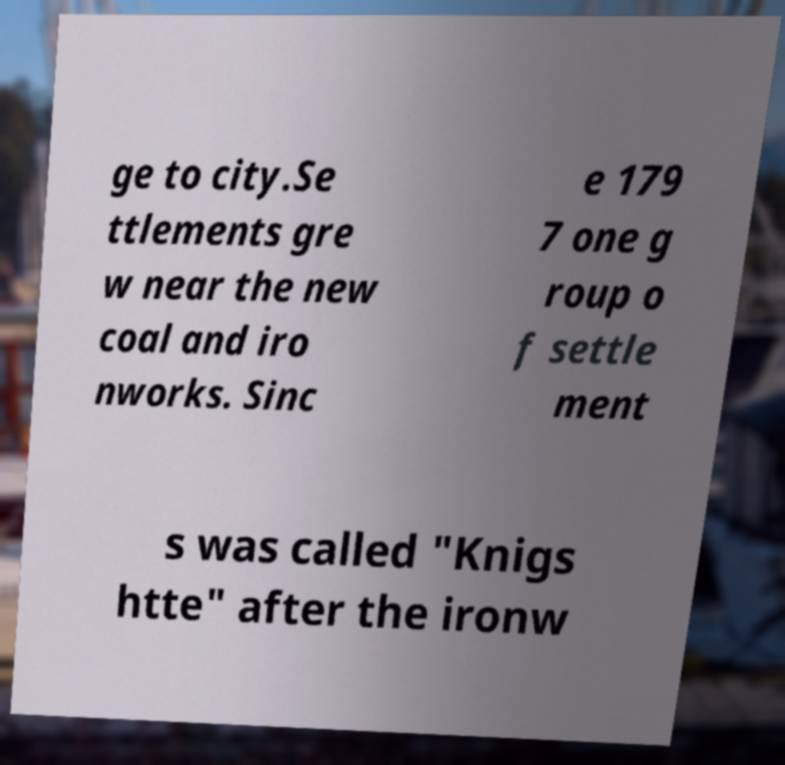Could you extract and type out the text from this image? ge to city.Se ttlements gre w near the new coal and iro nworks. Sinc e 179 7 one g roup o f settle ment s was called "Knigs htte" after the ironw 